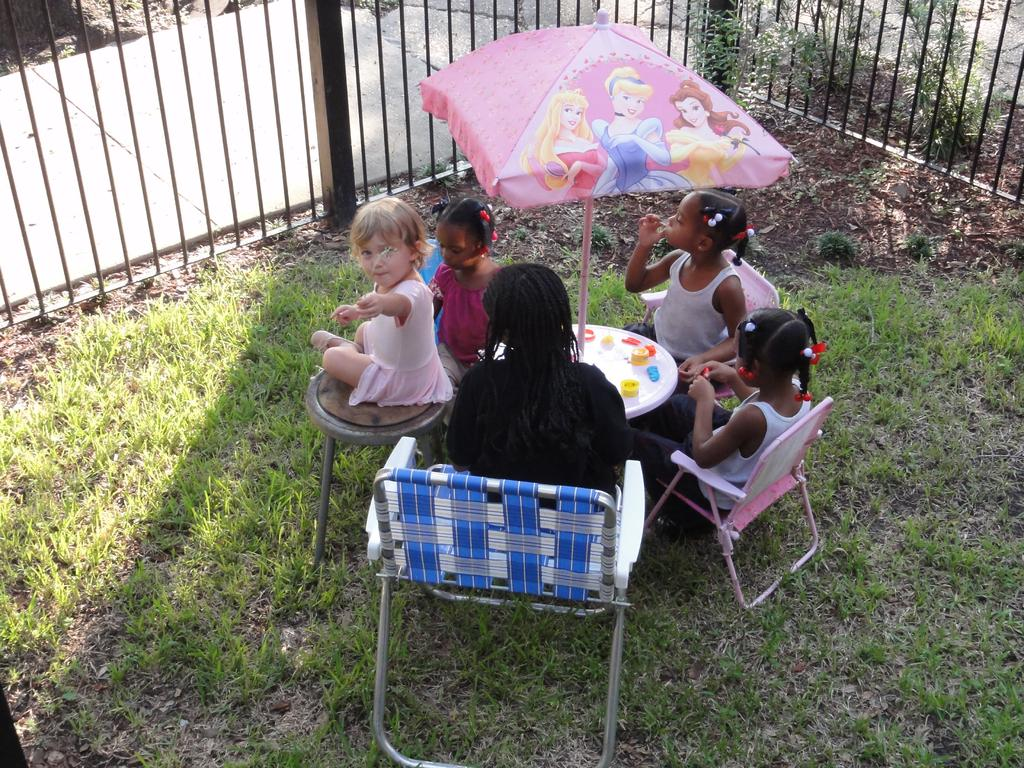What is the main subject of the image? The main subject of the image is a group of children. What are the children doing in the image? The children are sitting on chairs in the image. What is in front of the children? There is a table in front of the children. What is placed on the table? An umbrella is placed on the table. What is in front of the table? There is a railing in front of the children. What type of grass is growing on the children's hearts in the image? There is no grass or mention of hearts in the image; it features a group of children sitting on chairs with a table, umbrella, and railing in front of them. 